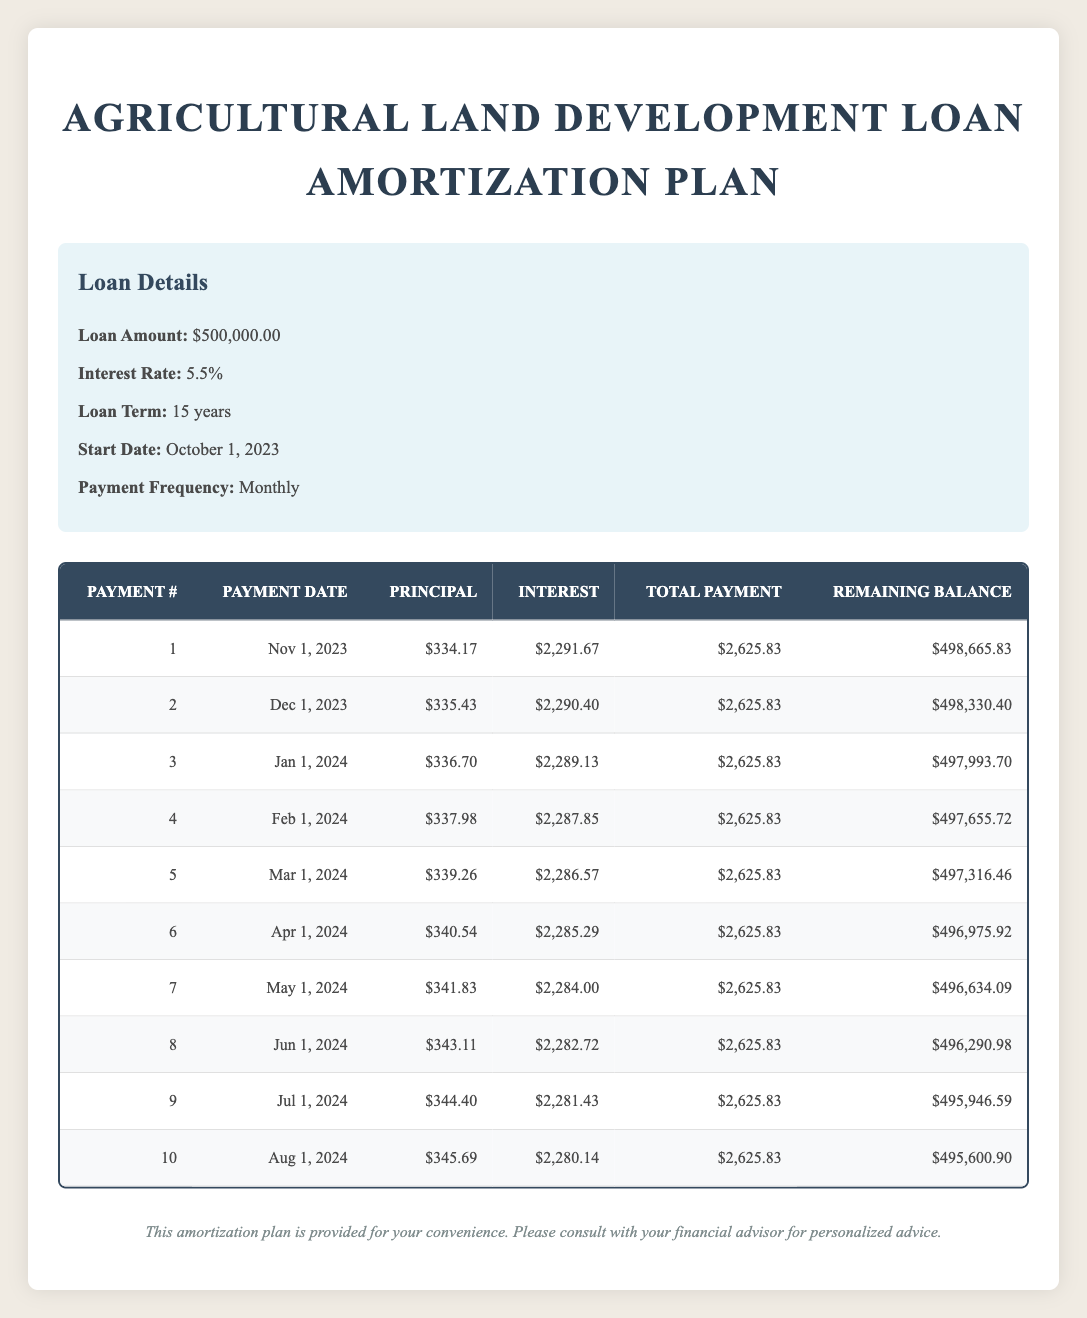What is the total payment for the first month? The total payment for the first month can be found in the amortization table under the "Total Payment" column for payment number 1, which is listed as 2,625.83.
Answer: 2,625.83 What is the principal payment for the second month? The principal payment for the second month is recorded in the amortization table under the "Principal" column for payment number 2, which is 335.43.
Answer: 335.43 What is the remaining balance after the third payment? To find the remaining balance after the third payment, we can look at the "Remaining Balance" column for payment number 3, which is 497,993.70.
Answer: 497,993.70 Does the total payment remain the same each month? By examining the "Total Payment" column for each month in the table, we can see that it consistently lists 2,625.83 for all payments, confirming that the total payment does remain constant.
Answer: Yes What is the total interest paid in the first three months? The total interest paid can be calculated by summing the interest payments for the first three months: 2,291.67 + 2,290.40 + 2,289.13. This equals 6,871.20, which is the total interest paid for the first three months.
Answer: 6,871.20 How much principal is paid off in the first six months combined? To find the total principal paid off in the first six months, we sum the principal payments from the first to the sixth month: 334.17 + 335.43 + 336.70 + 337.98 + 339.26 + 340.54 = 1,923.08.
Answer: 1,923.08 What is the average monthly principal payment for the first five months? The average monthly principal payment can be determined by adding the principal payments of the first five months: (334.17 + 335.43 + 336.70 + 337.98 + 339.26) / 5 = 334.92.
Answer: 334.92 Which payment has the lowest interest amount and what is that amount? By reviewing the "Interest" column in the amortization table, we find the lowest interest amount among the listed payments, which occurs in payment number 10, showing 2,280.14.
Answer: 2,280.14 Is the principal payment increasing every month and by how much on average? To determine if the principal payment is increasing each month, we analyze the principal payments. The increase from the first payment to the second is 1.26, from second to third is 1.27, and this continues to rise. On average, the increase in principal payments over these increases can be calculated as: (1.26 + 1.27 + 1.28 + 1.28 + 1.28) / 5 = about 1.27. Therefore, the principal payment is indeed increasing.
Answer: Yes, increasing by about 1.27 